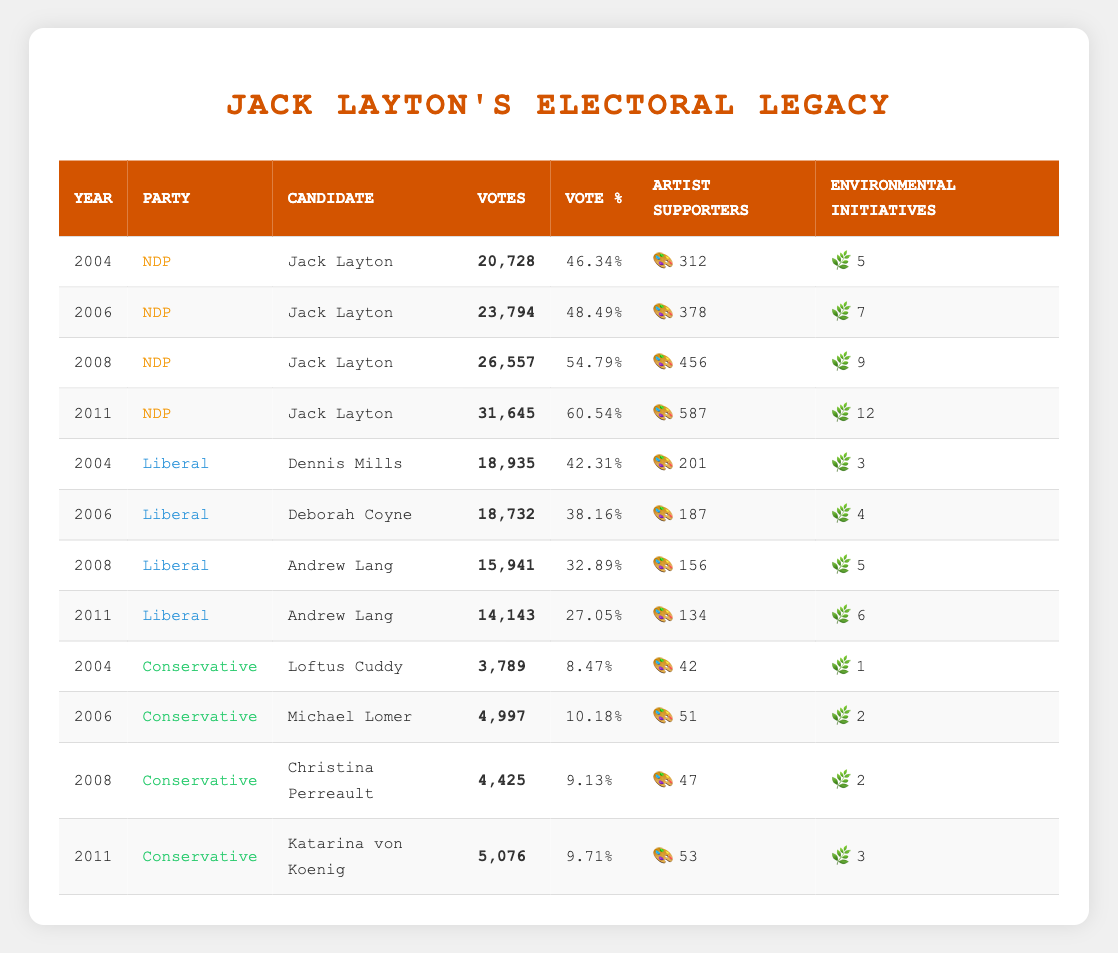What was Jack Layton's highest vote percentage, and in what year did it occur? In the table, we look for the "Vote %" column under Jack Layton's entries. The highest percentage is 60.54, which corresponds to the year 2011.
Answer: 60.54 in 2011 How many votes did Jack Layton receive in 2008? We find the row for 2008 and refer to the "Votes" column where Jack Layton is listed. He received 26,557 votes in that year.
Answer: 26,557 What is the total number of votes for the Liberal party between 2004 and 2011? We sum the "Votes" from all rows where the Party is Liberal from the given years: 18,935 + 18,732 + 15,941 + 14,143 = 67,751.
Answer: 67,751 Did the number of artist supporters for Jack Layton increase every election from 2004 to 2011? Checking the "Artist Supporters" column for Jack Layton, the values are 312, 378, 456, and 587, respectively. Each number is greater than the previous year, confirming a consistent increase.
Answer: Yes What was the average number of environmental initiatives per year for Jack Layton from 2004 to 2011? We total the "Environmental Initiatives" for Jack Layton: 5 + 7 + 9 + 12 = 33. Since there are 4 years (2004, 2006, 2008, 2011), we divide 33 by 4, giving us an average of 8.25.
Answer: 8.25 Which party had the highest number of artist supporters in 2011? In 2011, comparing the rows, the Liberal party had 134, Conservative had 53, and the NDP (Jack Layton) had 587 artist supporters. Clearly, the NDP had the highest number.
Answer: NDP What was the difference in votes received by the NDP and the Conservatives in 2006? In 2006, the NDP received 23,794 votes, and the Conservatives received 4,997 votes. The difference is calculated as 23,794 - 4,997 = 18,797.
Answer: 18,797 Which party saw a decrease in votes from 2004 to 2011? Looking at the Liberal party, their votes decreased from 18,935 in 2004 to 14,143 in 2011. For the Conservative party, they only slightly increased from 3,789 to 5,076. The Liberal party experienced a clear decrease.
Answer: Liberal party 